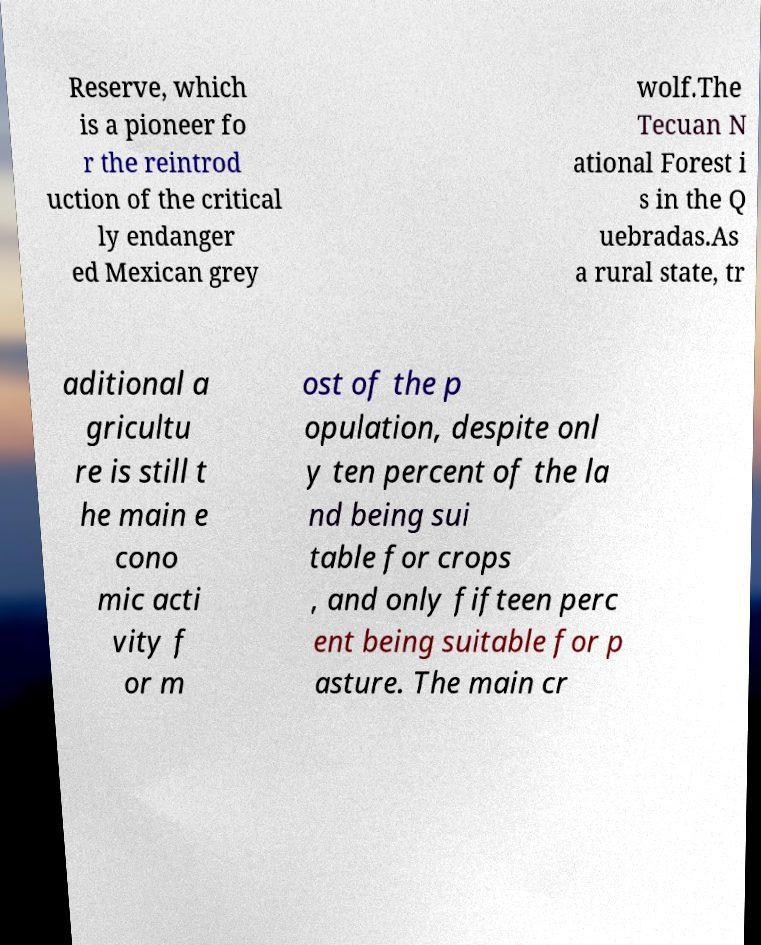For documentation purposes, I need the text within this image transcribed. Could you provide that? Reserve, which is a pioneer fo r the reintrod uction of the critical ly endanger ed Mexican grey wolf.The Tecuan N ational Forest i s in the Q uebradas.As a rural state, tr aditional a gricultu re is still t he main e cono mic acti vity f or m ost of the p opulation, despite onl y ten percent of the la nd being sui table for crops , and only fifteen perc ent being suitable for p asture. The main cr 